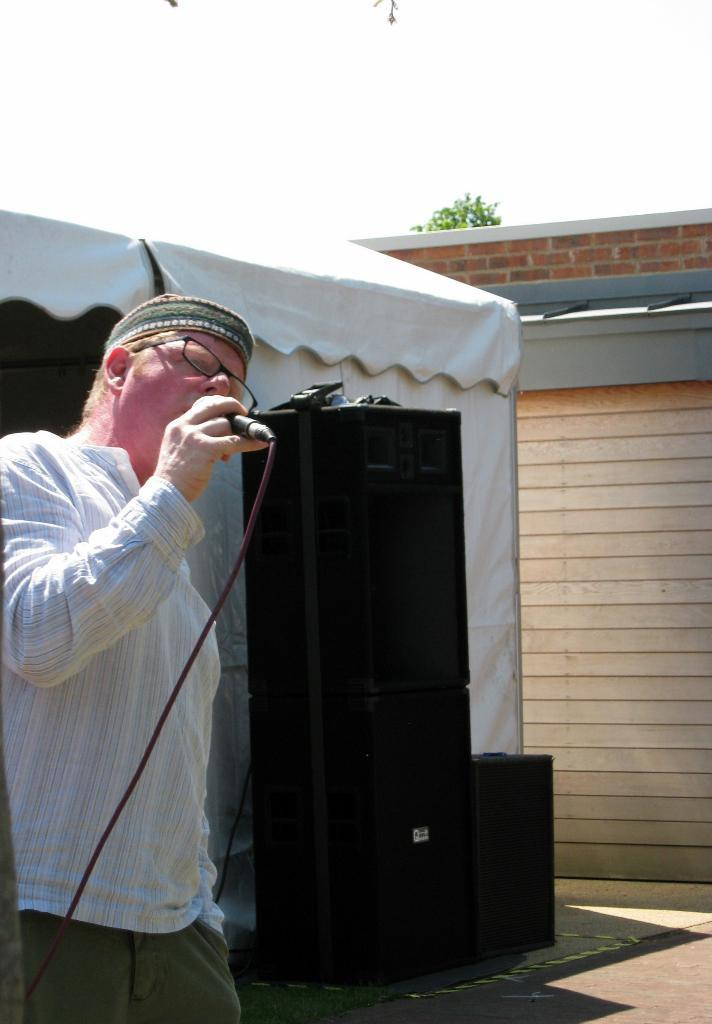What is the main subject of the image? There is a person in the image. What is the person doing in the image? The person is standing and singing. What object is in front of the person? There is a mic in front of the person. What type of equipment is present beside the person? There are black speakers beside the person. How many pies does the person have on their head in the image? There are no pies present on the person's head in the image. What type of lift is visible in the image? There is no lift visible in the image. 